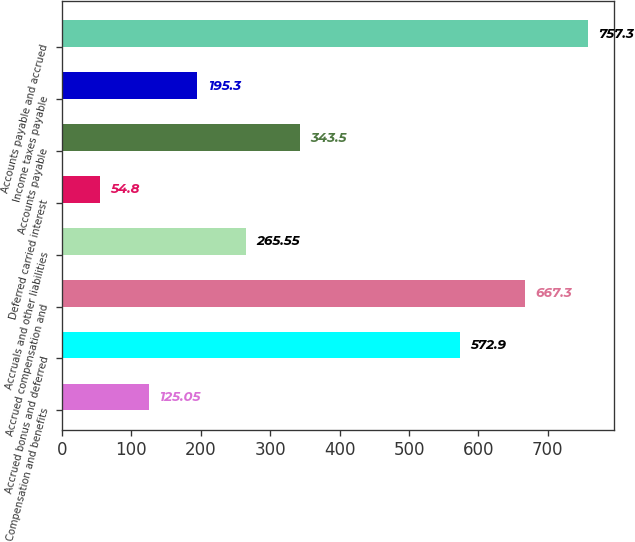<chart> <loc_0><loc_0><loc_500><loc_500><bar_chart><fcel>Compensation and benefits<fcel>Accrued bonus and deferred<fcel>Accrued compensation and<fcel>Accruals and other liabilities<fcel>Deferred carried interest<fcel>Accounts payable<fcel>Income taxes payable<fcel>Accounts payable and accrued<nl><fcel>125.05<fcel>572.9<fcel>667.3<fcel>265.55<fcel>54.8<fcel>343.5<fcel>195.3<fcel>757.3<nl></chart> 